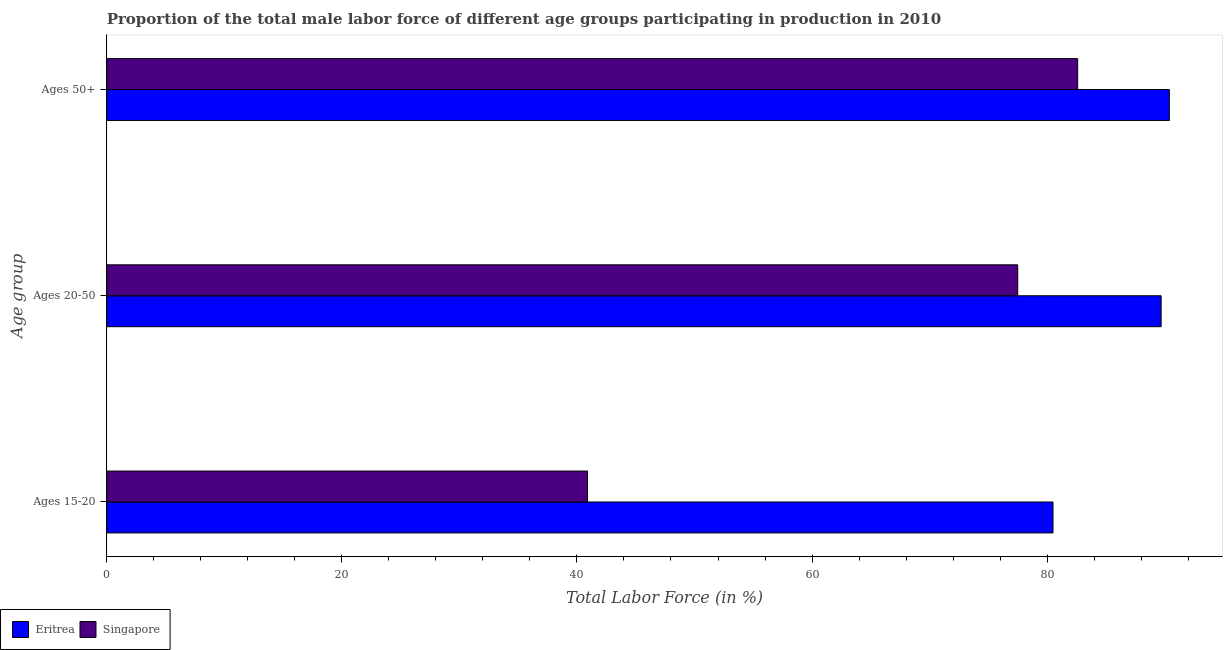Are the number of bars on each tick of the Y-axis equal?
Ensure brevity in your answer.  Yes. How many bars are there on the 3rd tick from the top?
Your answer should be very brief. 2. What is the label of the 2nd group of bars from the top?
Offer a terse response. Ages 20-50. What is the percentage of male labor force within the age group 20-50 in Singapore?
Offer a terse response. 77.5. Across all countries, what is the maximum percentage of male labor force within the age group 15-20?
Your answer should be compact. 80.5. Across all countries, what is the minimum percentage of male labor force within the age group 20-50?
Offer a very short reply. 77.5. In which country was the percentage of male labor force within the age group 20-50 maximum?
Provide a short and direct response. Eritrea. In which country was the percentage of male labor force above age 50 minimum?
Offer a very short reply. Singapore. What is the total percentage of male labor force within the age group 20-50 in the graph?
Make the answer very short. 167.2. What is the difference between the percentage of male labor force within the age group 15-20 in Eritrea and that in Singapore?
Provide a succinct answer. 39.6. What is the difference between the percentage of male labor force above age 50 in Eritrea and the percentage of male labor force within the age group 15-20 in Singapore?
Provide a succinct answer. 49.5. What is the average percentage of male labor force within the age group 20-50 per country?
Ensure brevity in your answer.  83.6. What is the difference between the percentage of male labor force within the age group 15-20 and percentage of male labor force within the age group 20-50 in Eritrea?
Provide a succinct answer. -9.2. In how many countries, is the percentage of male labor force within the age group 20-50 greater than 44 %?
Keep it short and to the point. 2. What is the ratio of the percentage of male labor force within the age group 15-20 in Singapore to that in Eritrea?
Offer a very short reply. 0.51. Is the percentage of male labor force within the age group 15-20 in Eritrea less than that in Singapore?
Your answer should be compact. No. What is the difference between the highest and the second highest percentage of male labor force within the age group 15-20?
Offer a terse response. 39.6. What is the difference between the highest and the lowest percentage of male labor force within the age group 15-20?
Make the answer very short. 39.6. Is the sum of the percentage of male labor force above age 50 in Eritrea and Singapore greater than the maximum percentage of male labor force within the age group 15-20 across all countries?
Give a very brief answer. Yes. What does the 1st bar from the top in Ages 15-20 represents?
Your answer should be compact. Singapore. What does the 2nd bar from the bottom in Ages 15-20 represents?
Your answer should be very brief. Singapore. How many bars are there?
Provide a short and direct response. 6. What is the difference between two consecutive major ticks on the X-axis?
Offer a very short reply. 20. Does the graph contain any zero values?
Offer a very short reply. No. Does the graph contain grids?
Keep it short and to the point. No. How many legend labels are there?
Offer a terse response. 2. How are the legend labels stacked?
Your answer should be very brief. Horizontal. What is the title of the graph?
Give a very brief answer. Proportion of the total male labor force of different age groups participating in production in 2010. What is the label or title of the Y-axis?
Your answer should be very brief. Age group. What is the Total Labor Force (in %) in Eritrea in Ages 15-20?
Offer a very short reply. 80.5. What is the Total Labor Force (in %) in Singapore in Ages 15-20?
Your answer should be compact. 40.9. What is the Total Labor Force (in %) of Eritrea in Ages 20-50?
Keep it short and to the point. 89.7. What is the Total Labor Force (in %) of Singapore in Ages 20-50?
Your answer should be very brief. 77.5. What is the Total Labor Force (in %) in Eritrea in Ages 50+?
Your answer should be very brief. 90.4. What is the Total Labor Force (in %) of Singapore in Ages 50+?
Your response must be concise. 82.6. Across all Age group, what is the maximum Total Labor Force (in %) of Eritrea?
Give a very brief answer. 90.4. Across all Age group, what is the maximum Total Labor Force (in %) in Singapore?
Keep it short and to the point. 82.6. Across all Age group, what is the minimum Total Labor Force (in %) of Eritrea?
Provide a succinct answer. 80.5. Across all Age group, what is the minimum Total Labor Force (in %) in Singapore?
Your response must be concise. 40.9. What is the total Total Labor Force (in %) in Eritrea in the graph?
Keep it short and to the point. 260.6. What is the total Total Labor Force (in %) of Singapore in the graph?
Make the answer very short. 201. What is the difference between the Total Labor Force (in %) of Eritrea in Ages 15-20 and that in Ages 20-50?
Your answer should be very brief. -9.2. What is the difference between the Total Labor Force (in %) of Singapore in Ages 15-20 and that in Ages 20-50?
Make the answer very short. -36.6. What is the difference between the Total Labor Force (in %) in Singapore in Ages 15-20 and that in Ages 50+?
Your response must be concise. -41.7. What is the difference between the Total Labor Force (in %) of Singapore in Ages 20-50 and that in Ages 50+?
Keep it short and to the point. -5.1. What is the difference between the Total Labor Force (in %) of Eritrea in Ages 15-20 and the Total Labor Force (in %) of Singapore in Ages 20-50?
Give a very brief answer. 3. What is the difference between the Total Labor Force (in %) in Eritrea in Ages 20-50 and the Total Labor Force (in %) in Singapore in Ages 50+?
Keep it short and to the point. 7.1. What is the average Total Labor Force (in %) in Eritrea per Age group?
Your response must be concise. 86.87. What is the difference between the Total Labor Force (in %) in Eritrea and Total Labor Force (in %) in Singapore in Ages 15-20?
Offer a terse response. 39.6. What is the ratio of the Total Labor Force (in %) in Eritrea in Ages 15-20 to that in Ages 20-50?
Offer a terse response. 0.9. What is the ratio of the Total Labor Force (in %) of Singapore in Ages 15-20 to that in Ages 20-50?
Ensure brevity in your answer.  0.53. What is the ratio of the Total Labor Force (in %) of Eritrea in Ages 15-20 to that in Ages 50+?
Your answer should be very brief. 0.89. What is the ratio of the Total Labor Force (in %) of Singapore in Ages 15-20 to that in Ages 50+?
Offer a very short reply. 0.5. What is the ratio of the Total Labor Force (in %) of Singapore in Ages 20-50 to that in Ages 50+?
Your response must be concise. 0.94. What is the difference between the highest and the lowest Total Labor Force (in %) of Eritrea?
Ensure brevity in your answer.  9.9. What is the difference between the highest and the lowest Total Labor Force (in %) of Singapore?
Your answer should be compact. 41.7. 